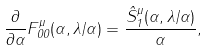<formula> <loc_0><loc_0><loc_500><loc_500>\frac { \partial } { \partial \alpha } F ^ { \mu } _ { 0 0 } ( \alpha , \lambda / \alpha ) = \frac { \hat { S } _ { 1 } ^ { \mu } ( \alpha , \lambda / \alpha ) } { \alpha } ,</formula> 